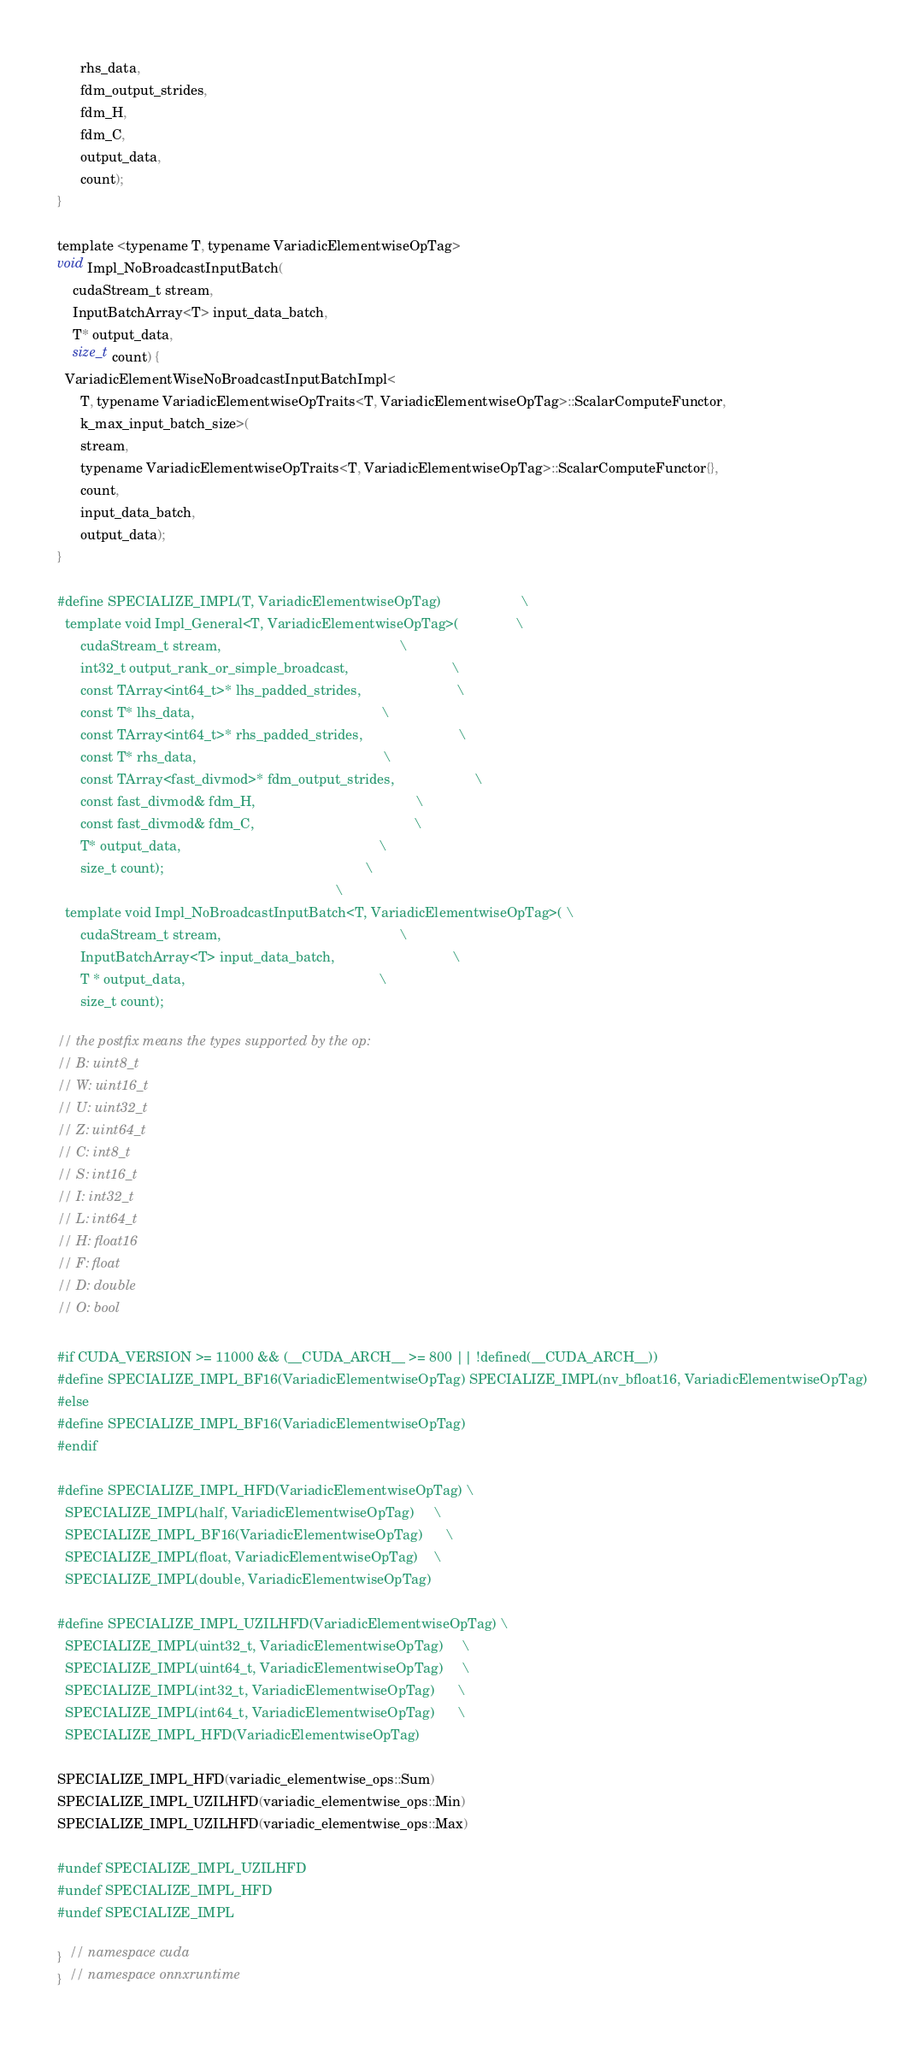<code> <loc_0><loc_0><loc_500><loc_500><_Cuda_>      rhs_data,
      fdm_output_strides,
      fdm_H,
      fdm_C,
      output_data,
      count);
}

template <typename T, typename VariadicElementwiseOpTag>
void Impl_NoBroadcastInputBatch(
    cudaStream_t stream,
    InputBatchArray<T> input_data_batch,
    T* output_data,
    size_t count) {
  VariadicElementWiseNoBroadcastInputBatchImpl<
      T, typename VariadicElementwiseOpTraits<T, VariadicElementwiseOpTag>::ScalarComputeFunctor,
      k_max_input_batch_size>(
      stream,
      typename VariadicElementwiseOpTraits<T, VariadicElementwiseOpTag>::ScalarComputeFunctor{},
      count,
      input_data_batch,
      output_data);
}

#define SPECIALIZE_IMPL(T, VariadicElementwiseOpTag)                     \
  template void Impl_General<T, VariadicElementwiseOpTag>(               \
      cudaStream_t stream,                                               \
      int32_t output_rank_or_simple_broadcast,                           \
      const TArray<int64_t>* lhs_padded_strides,                         \
      const T* lhs_data,                                                 \
      const TArray<int64_t>* rhs_padded_strides,                         \
      const T* rhs_data,                                                 \
      const TArray<fast_divmod>* fdm_output_strides,                     \
      const fast_divmod& fdm_H,                                          \
      const fast_divmod& fdm_C,                                          \
      T* output_data,                                                    \
      size_t count);                                                     \
                                                                         \
  template void Impl_NoBroadcastInputBatch<T, VariadicElementwiseOpTag>( \
      cudaStream_t stream,                                               \
      InputBatchArray<T> input_data_batch,                               \
      T * output_data,                                                   \
      size_t count);

// the postfix means the types supported by the op:
// B: uint8_t
// W: uint16_t
// U: uint32_t
// Z: uint64_t
// C: int8_t
// S: int16_t
// I: int32_t
// L: int64_t
// H: float16
// F: float
// D: double
// O: bool

#if CUDA_VERSION >= 11000 && (__CUDA_ARCH__ >= 800 || !defined(__CUDA_ARCH__))
#define SPECIALIZE_IMPL_BF16(VariadicElementwiseOpTag) SPECIALIZE_IMPL(nv_bfloat16, VariadicElementwiseOpTag)
#else
#define SPECIALIZE_IMPL_BF16(VariadicElementwiseOpTag)
#endif

#define SPECIALIZE_IMPL_HFD(VariadicElementwiseOpTag) \
  SPECIALIZE_IMPL(half, VariadicElementwiseOpTag)     \
  SPECIALIZE_IMPL_BF16(VariadicElementwiseOpTag)      \
  SPECIALIZE_IMPL(float, VariadicElementwiseOpTag)    \
  SPECIALIZE_IMPL(double, VariadicElementwiseOpTag)

#define SPECIALIZE_IMPL_UZILHFD(VariadicElementwiseOpTag) \
  SPECIALIZE_IMPL(uint32_t, VariadicElementwiseOpTag)     \
  SPECIALIZE_IMPL(uint64_t, VariadicElementwiseOpTag)     \
  SPECIALIZE_IMPL(int32_t, VariadicElementwiseOpTag)      \
  SPECIALIZE_IMPL(int64_t, VariadicElementwiseOpTag)      \
  SPECIALIZE_IMPL_HFD(VariadicElementwiseOpTag)

SPECIALIZE_IMPL_HFD(variadic_elementwise_ops::Sum)
SPECIALIZE_IMPL_UZILHFD(variadic_elementwise_ops::Min)
SPECIALIZE_IMPL_UZILHFD(variadic_elementwise_ops::Max)

#undef SPECIALIZE_IMPL_UZILHFD
#undef SPECIALIZE_IMPL_HFD
#undef SPECIALIZE_IMPL

}  // namespace cuda
}  // namespace onnxruntime
</code> 